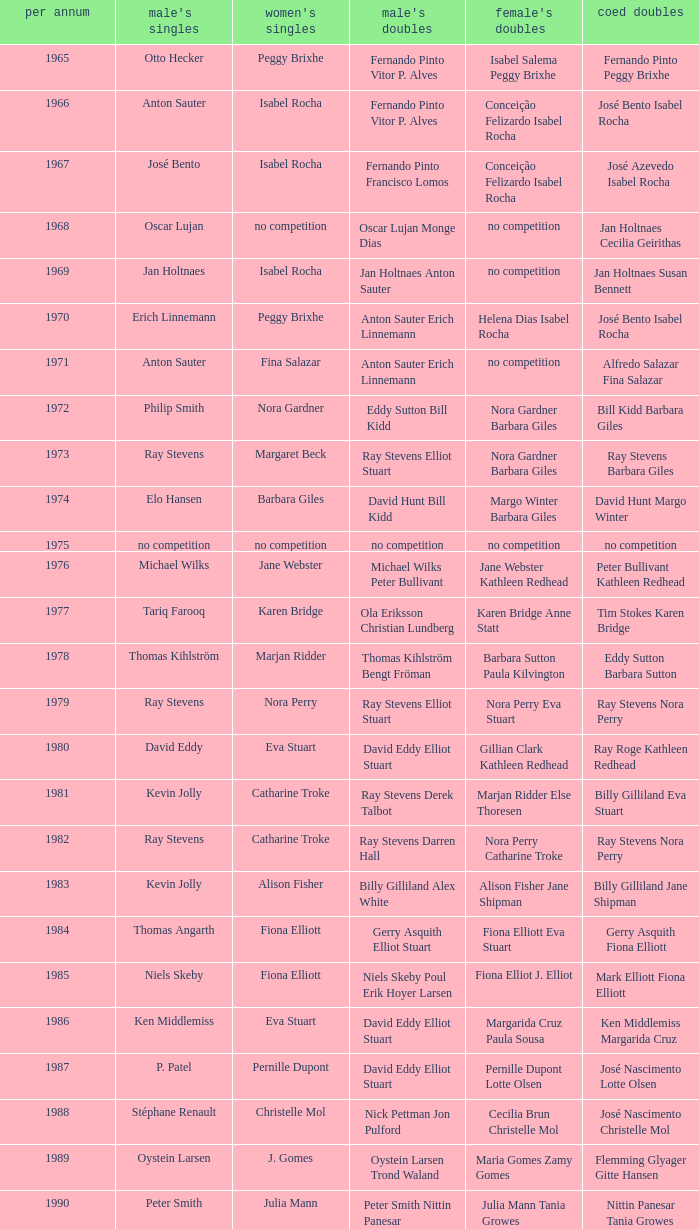What is the average year with alfredo salazar fina salazar in mixed doubles? 1971.0. 